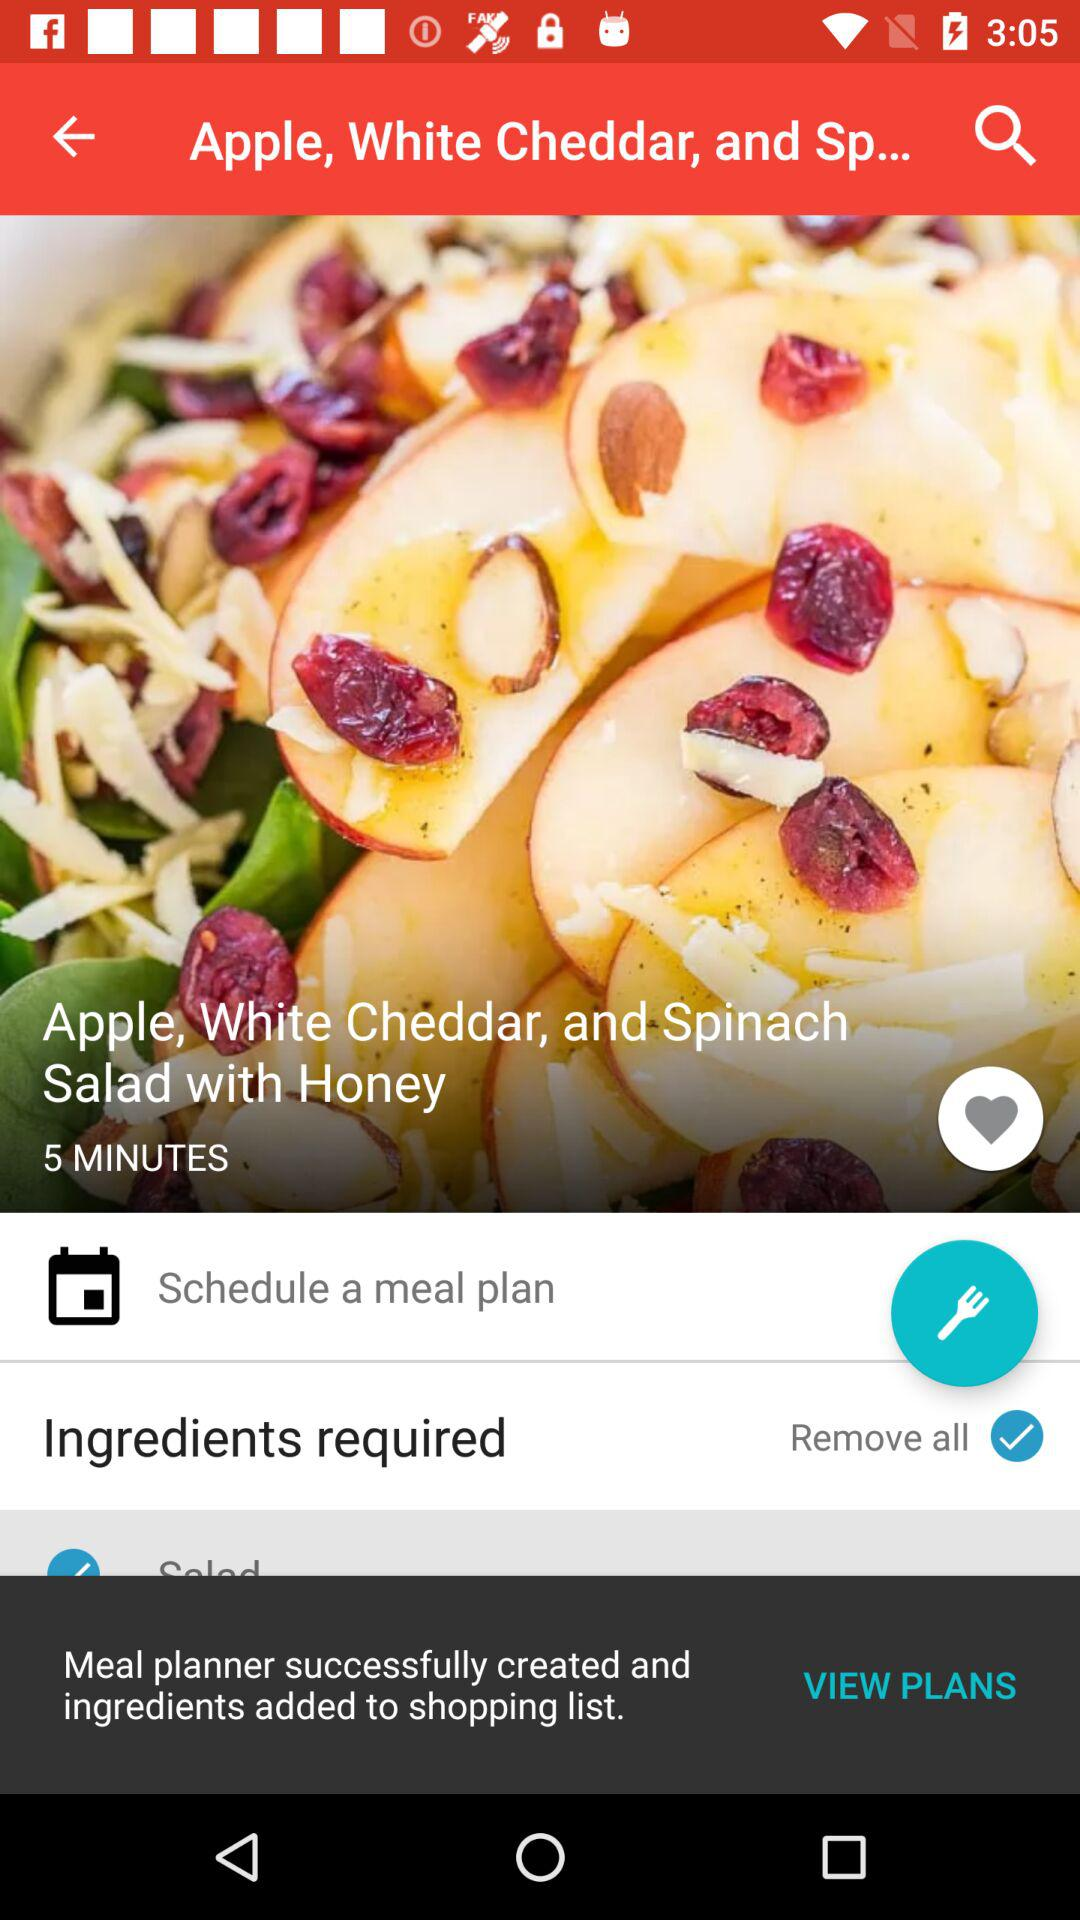How much time will it take to make the dish? It will take 5 minutes to make the dish. 